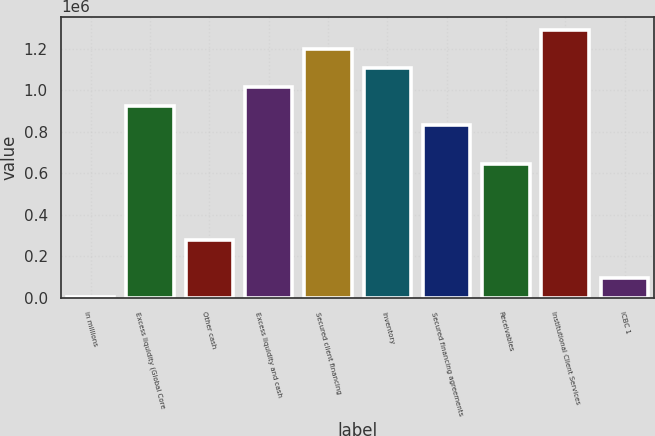Convert chart to OTSL. <chart><loc_0><loc_0><loc_500><loc_500><bar_chart><fcel>in millions<fcel>Excess liquidity (Global Core<fcel>Other cash<fcel>Excess liquidity and cash<fcel>Secured client financing<fcel>Inventory<fcel>Secured financing agreements<fcel>Receivables<fcel>Institutional Client Services<fcel>ICBC 1<nl><fcel>2011<fcel>923225<fcel>278375<fcel>1.01535e+06<fcel>1.19959e+06<fcel>1.10747e+06<fcel>831104<fcel>646861<fcel>1.29171e+06<fcel>94132.4<nl></chart> 